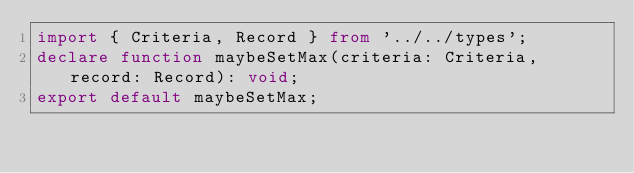<code> <loc_0><loc_0><loc_500><loc_500><_TypeScript_>import { Criteria, Record } from '../../types';
declare function maybeSetMax(criteria: Criteria, record: Record): void;
export default maybeSetMax;
</code> 